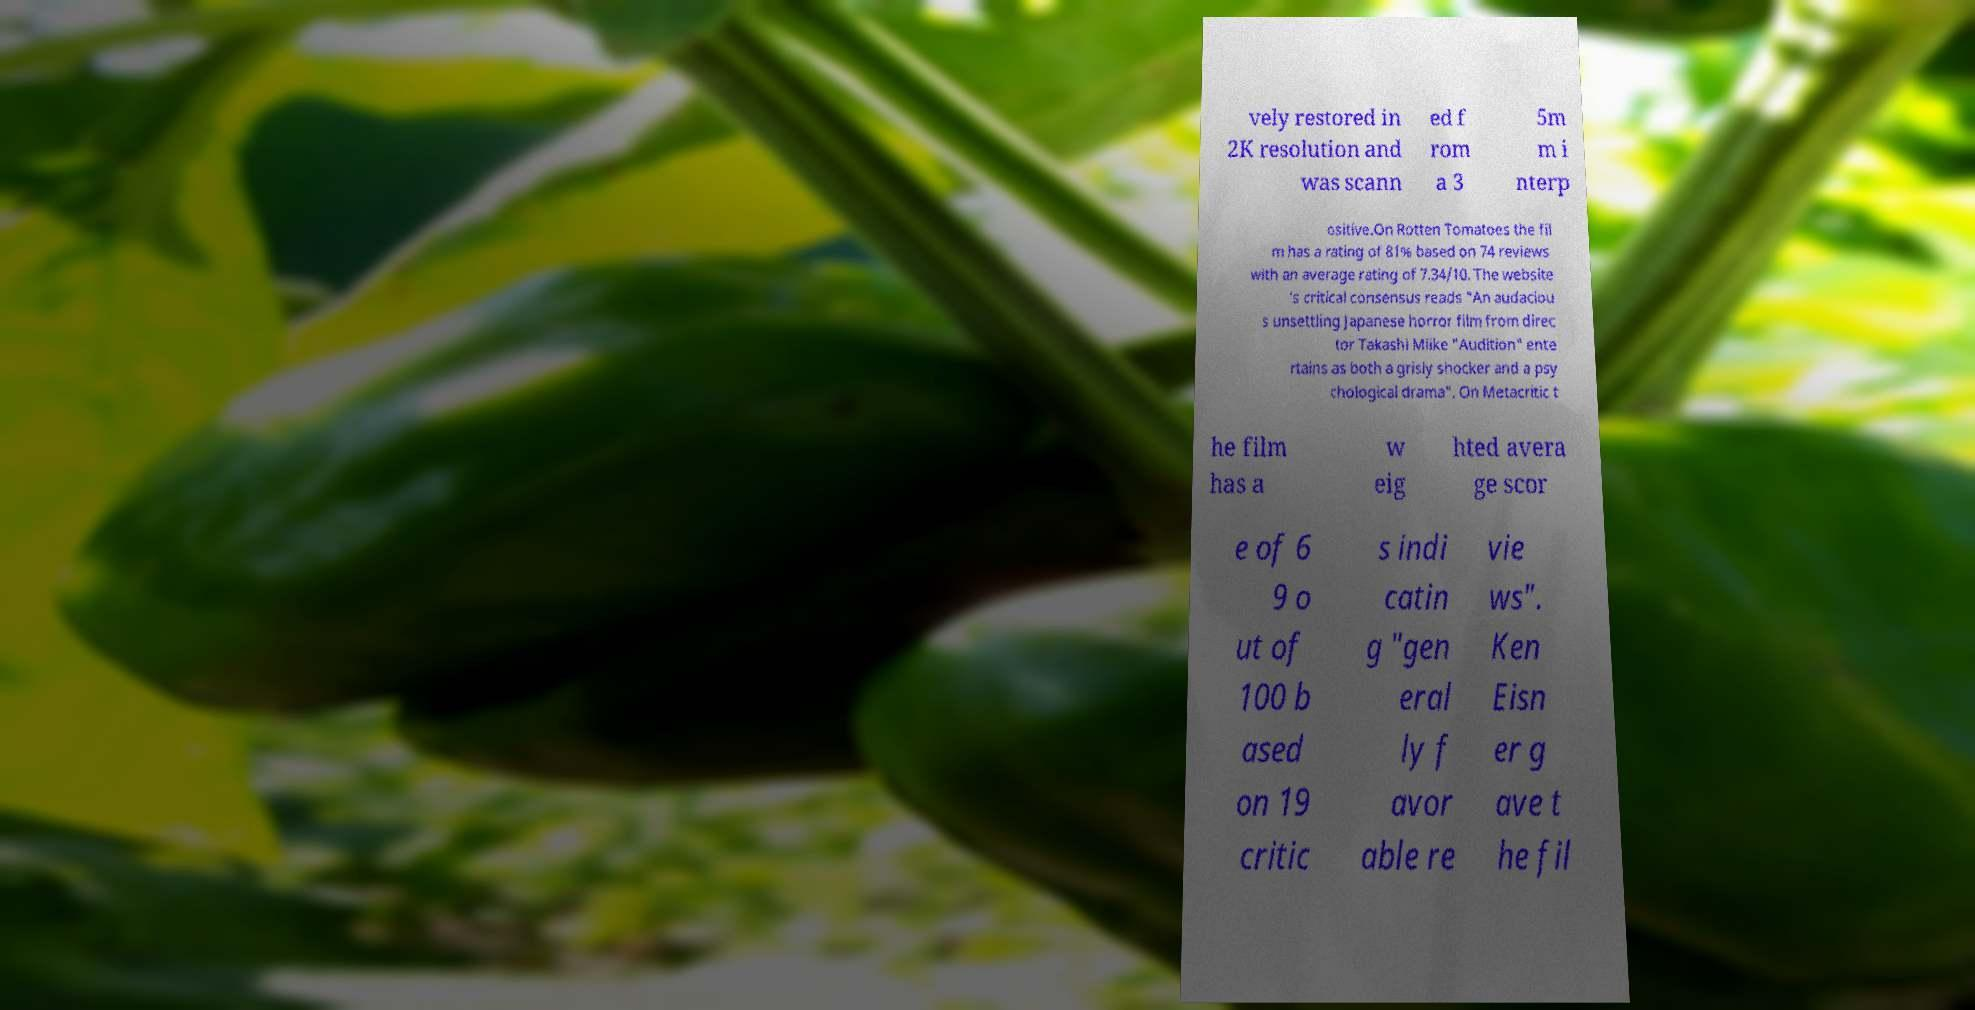What messages or text are displayed in this image? I need them in a readable, typed format. vely restored in 2K resolution and was scann ed f rom a 3 5m m i nterp ositive.On Rotten Tomatoes the fil m has a rating of 81% based on 74 reviews with an average rating of 7.34/10. The website 's critical consensus reads "An audaciou s unsettling Japanese horror film from direc tor Takashi Miike "Audition" ente rtains as both a grisly shocker and a psy chological drama". On Metacritic t he film has a w eig hted avera ge scor e of 6 9 o ut of 100 b ased on 19 critic s indi catin g "gen eral ly f avor able re vie ws". Ken Eisn er g ave t he fil 